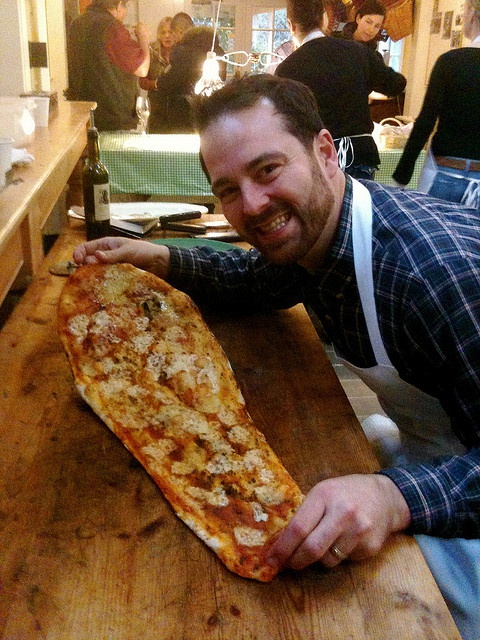Describe the objects in this image and their specific colors. I can see dining table in tan, maroon, brown, and black tones, people in tan, black, maroon, darkgray, and brown tones, pizza in tan, olive, and maroon tones, people in tan, black, and blue tones, and people in tan, black, maroon, and white tones in this image. 